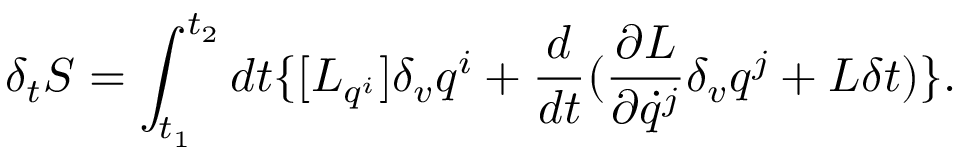Convert formula to latex. <formula><loc_0><loc_0><loc_500><loc_500>\delta _ { t } { S } = \int _ { t _ { 1 } } ^ { t _ { 2 } } d t \{ [ { L } _ { q ^ { i } } ] \delta _ { v } q ^ { i } + \frac { d } { d t } ( \frac { \partial { L } } { \partial \dot { q } ^ { j } } \delta _ { v } q ^ { j } + { L } \delta t ) \} .</formula> 